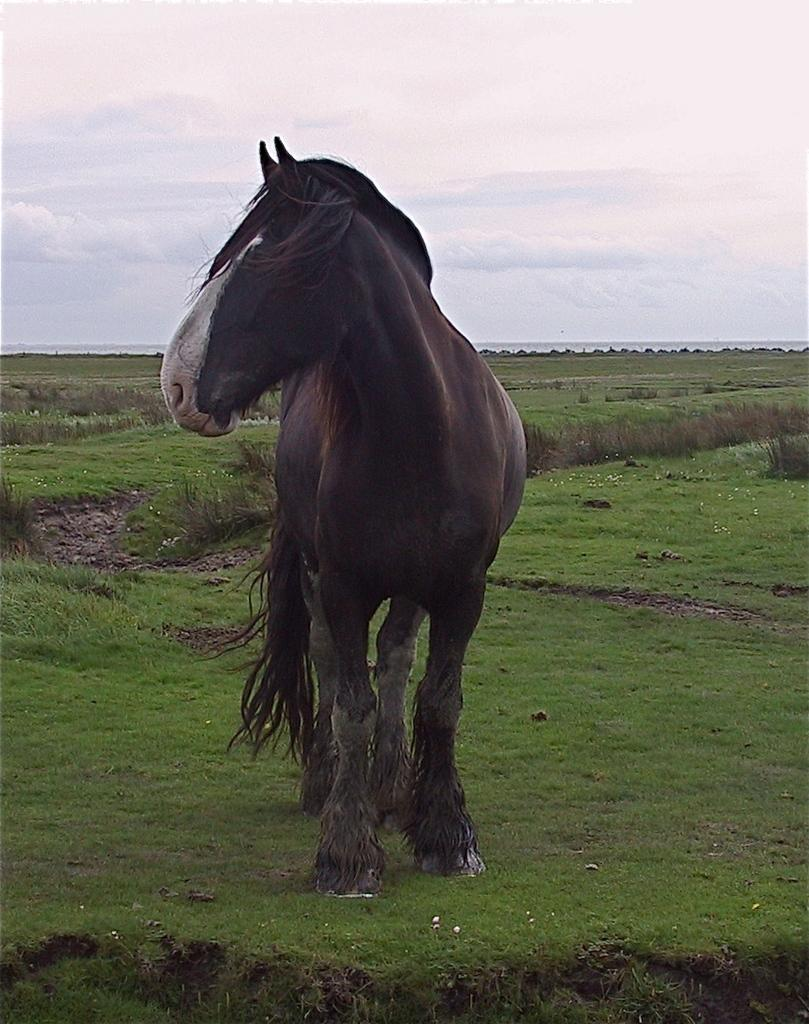What is the main subject in the center of the image? There is a horse in the center of the image. What type of terrain is visible at the bottom of the image? There is grass at the bottom of the image. What can be seen in the background of the image? There are plants in the background of the image. What is visible at the top of the image? The sky is visible at the top of the image. How many girls are in jail in the image? There are no girls or jails present in the image. 